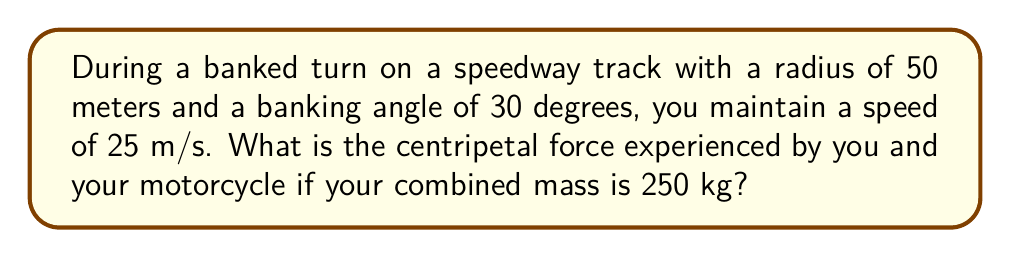Provide a solution to this math problem. To solve this problem, we'll follow these steps:

1) The centripetal force is given by the formula:

   $$F_c = \frac{mv^2}{r}$$

   where $m$ is the mass, $v$ is the velocity, and $r$ is the radius of the turn.

2) However, on a banked turn, part of the normal force contributes to the centripetal force. The effective centripetal force is:

   $$F_c = \frac{mv^2}{r} - mg\sin\theta$$

   where $g$ is the acceleration due to gravity and $\theta$ is the banking angle.

3) Let's substitute our known values:
   $m = 250$ kg
   $v = 25$ m/s
   $r = 50$ m
   $g = 9.8$ m/s²
   $\theta = 30°$

4) First, calculate $\frac{mv^2}{r}$:

   $$\frac{mv^2}{r} = \frac{250 \cdot 25^2}{50} = 3125\text{ N}$$

5) Next, calculate $mg\sin\theta$:

   $$mg\sin\theta = 250 \cdot 9.8 \cdot \sin(30°) = 1225\text{ N}$$

6) Now, subtract to get the effective centripetal force:

   $$F_c = 3125 - 1225 = 1900\text{ N}$$
Answer: 1900 N 